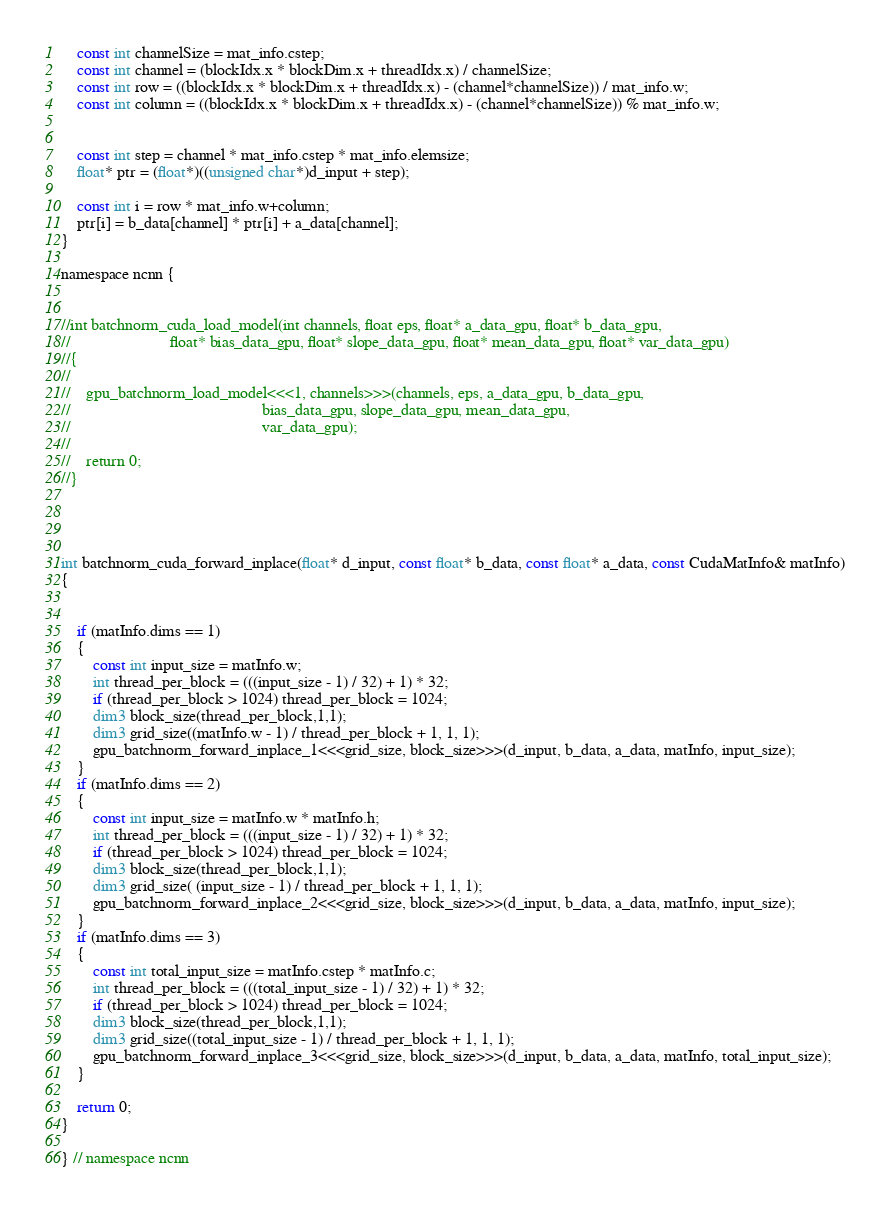Convert code to text. <code><loc_0><loc_0><loc_500><loc_500><_Cuda_>    const int channelSize = mat_info.cstep;
    const int channel = (blockIdx.x * blockDim.x + threadIdx.x) / channelSize;
    const int row = ((blockIdx.x * blockDim.x + threadIdx.x) - (channel*channelSize)) / mat_info.w;
    const int column = ((blockIdx.x * blockDim.x + threadIdx.x) - (channel*channelSize)) % mat_info.w;


    const int step = channel * mat_info.cstep * mat_info.elemsize;
    float* ptr = (float*)((unsigned char*)d_input + step);

    const int i = row * mat_info.w+column;
    ptr[i] = b_data[channel] * ptr[i] + a_data[channel];
}

namespace ncnn {


//int batchnorm_cuda_load_model(int channels, float eps, float* a_data_gpu, float* b_data_gpu,
//                         float* bias_data_gpu, float* slope_data_gpu, float* mean_data_gpu, float* var_data_gpu)
//{
//
//    gpu_batchnorm_load_model<<<1, channels>>>(channels, eps, a_data_gpu, b_data_gpu,
//                                                bias_data_gpu, slope_data_gpu, mean_data_gpu,
//                                                var_data_gpu);
//
//    return 0;
//}




int batchnorm_cuda_forward_inplace(float* d_input, const float* b_data, const float* a_data, const CudaMatInfo& matInfo)
{


    if (matInfo.dims == 1)
    {
        const int input_size = matInfo.w;
        int thread_per_block = (((input_size - 1) / 32) + 1) * 32;
        if (thread_per_block > 1024) thread_per_block = 1024;
        dim3 block_size(thread_per_block,1,1);
        dim3 grid_size((matInfo.w - 1) / thread_per_block + 1, 1, 1);
        gpu_batchnorm_forward_inplace_1<<<grid_size, block_size>>>(d_input, b_data, a_data, matInfo, input_size);
    }
    if (matInfo.dims == 2)
    {
        const int input_size = matInfo.w * matInfo.h;
        int thread_per_block = (((input_size - 1) / 32) + 1) * 32;
        if (thread_per_block > 1024) thread_per_block = 1024;
        dim3 block_size(thread_per_block,1,1);
        dim3 grid_size( (input_size - 1) / thread_per_block + 1, 1, 1);
        gpu_batchnorm_forward_inplace_2<<<grid_size, block_size>>>(d_input, b_data, a_data, matInfo, input_size);
    }
    if (matInfo.dims == 3)
    {
        const int total_input_size = matInfo.cstep * matInfo.c;
        int thread_per_block = (((total_input_size - 1) / 32) + 1) * 32;
        if (thread_per_block > 1024) thread_per_block = 1024;
        dim3 block_size(thread_per_block,1,1);
        dim3 grid_size((total_input_size - 1) / thread_per_block + 1, 1, 1);
        gpu_batchnorm_forward_inplace_3<<<grid_size, block_size>>>(d_input, b_data, a_data, matInfo, total_input_size);
    }

    return 0;
}

} // namespace ncnn
</code> 